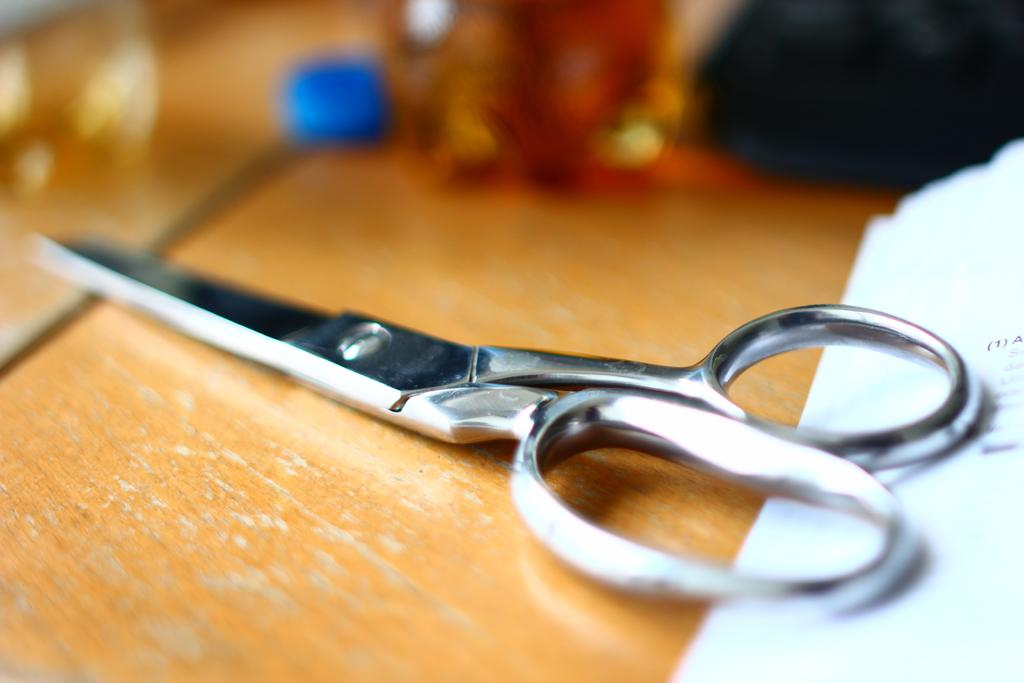What type of tool is visible in the image? There is a pair of scissors in the image. What is placed on the wooden object in the image? There is a paper on a wooden object in the image. What type of soup is being served by the fireman in the image? There is no soup, fireman, or shop present in the image. 